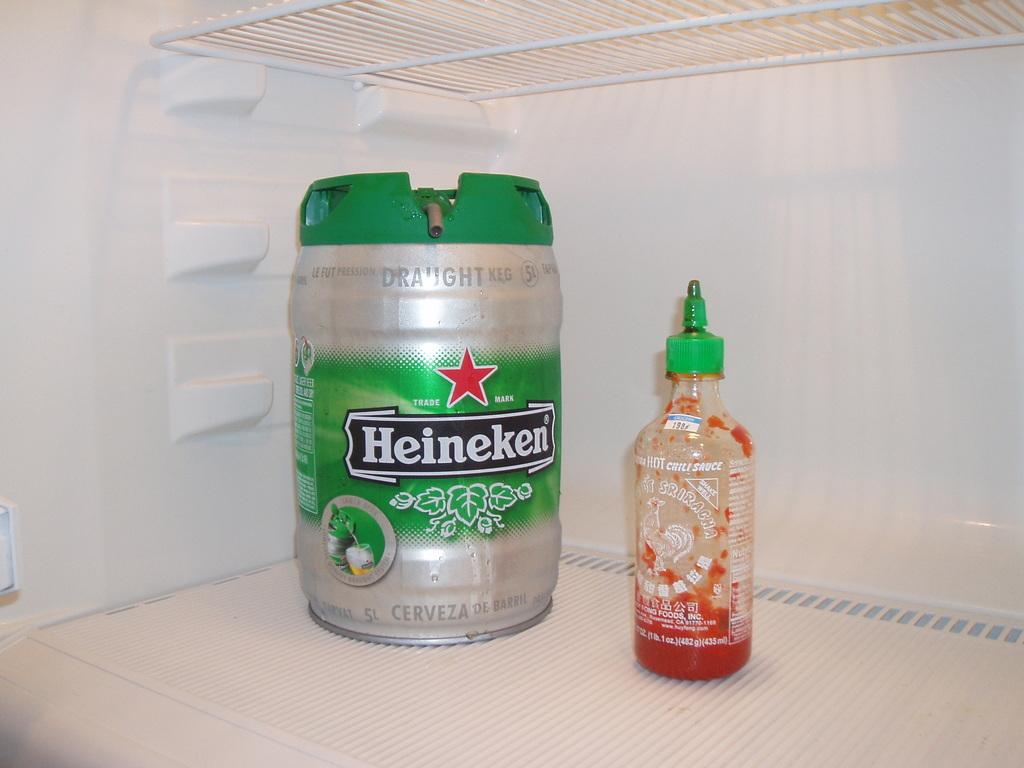<image>
Present a compact description of the photo's key features. Green and Silver Heineken can and a bottle of Sriracha Sauce. 